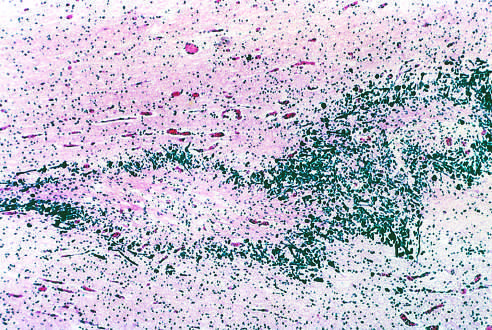does this specimen from a patient with periventricular leukomalacia contain a central focus of white matter necrosis with a peripheral rim of mineralized axonal processes?
Answer the question using a single word or phrase. Yes 